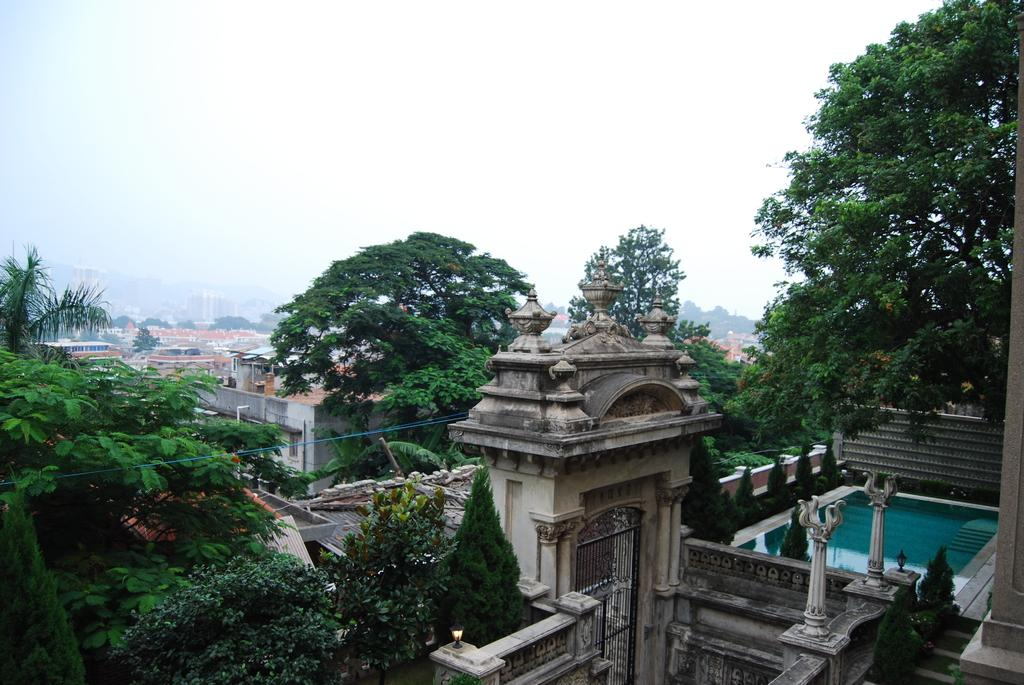What type of structures can be seen in the image? There are buildings in the image. What other elements are present in the image besides the buildings? There are gates, green trees, a pool, and lights in the image. What color is the sky in the image? The sky is blue and white in color. What type of shoe can be seen floating in the pool in the image? There is no shoe present in the image, and therefore no such object can be observed in the pool. 